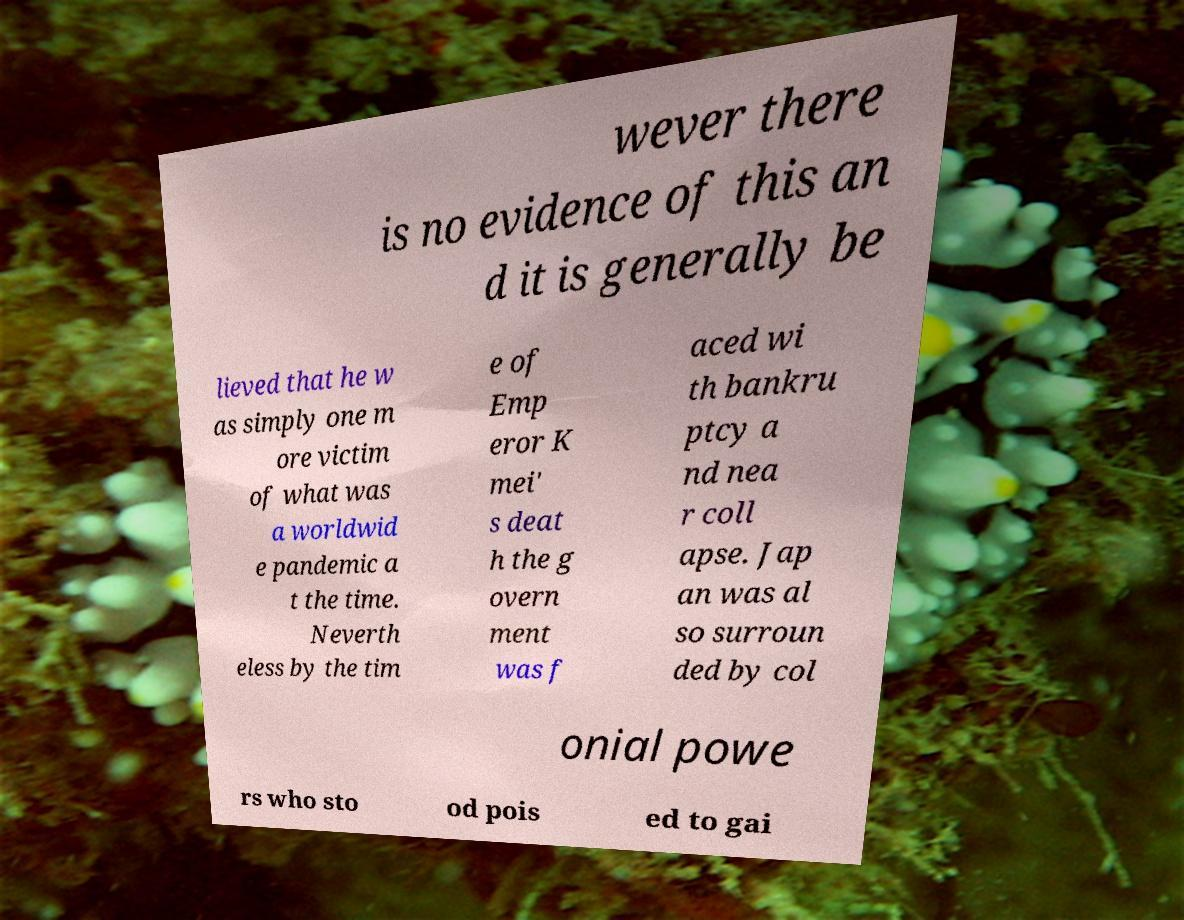What messages or text are displayed in this image? I need them in a readable, typed format. wever there is no evidence of this an d it is generally be lieved that he w as simply one m ore victim of what was a worldwid e pandemic a t the time. Neverth eless by the tim e of Emp eror K mei' s deat h the g overn ment was f aced wi th bankru ptcy a nd nea r coll apse. Jap an was al so surroun ded by col onial powe rs who sto od pois ed to gai 